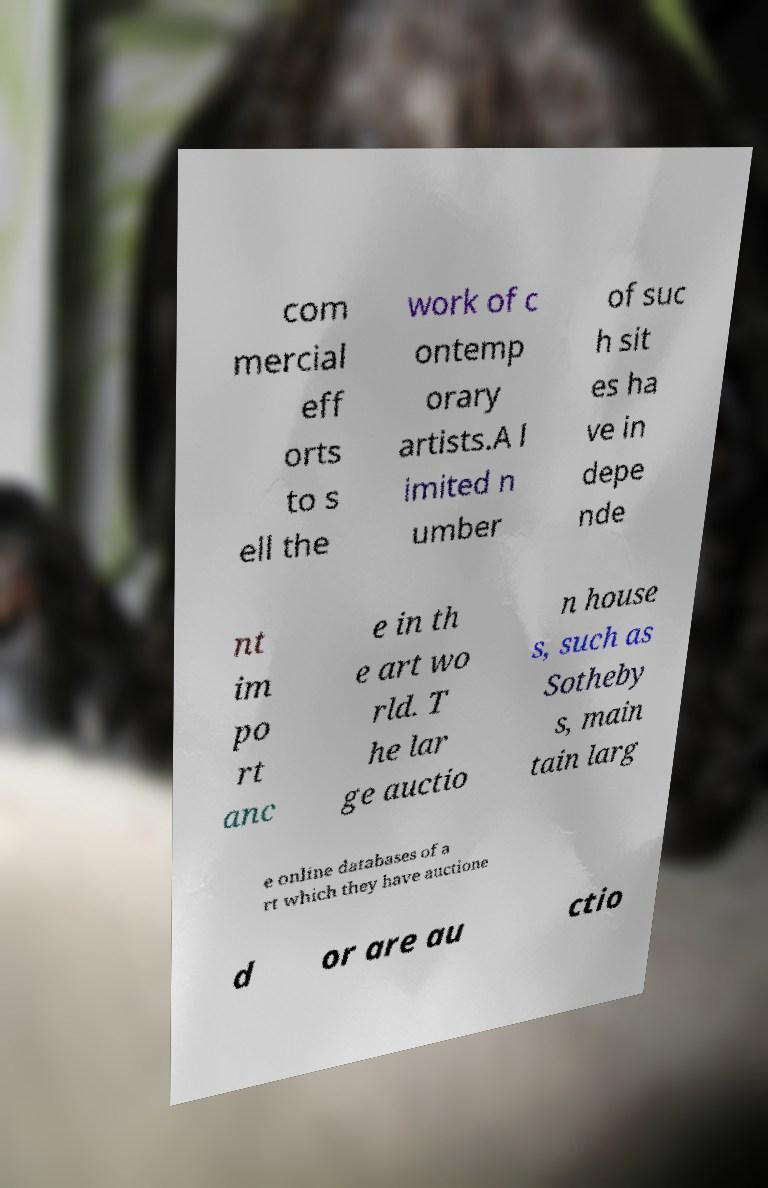There's text embedded in this image that I need extracted. Can you transcribe it verbatim? com mercial eff orts to s ell the work of c ontemp orary artists.A l imited n umber of suc h sit es ha ve in depe nde nt im po rt anc e in th e art wo rld. T he lar ge auctio n house s, such as Sotheby s, main tain larg e online databases of a rt which they have auctione d or are au ctio 